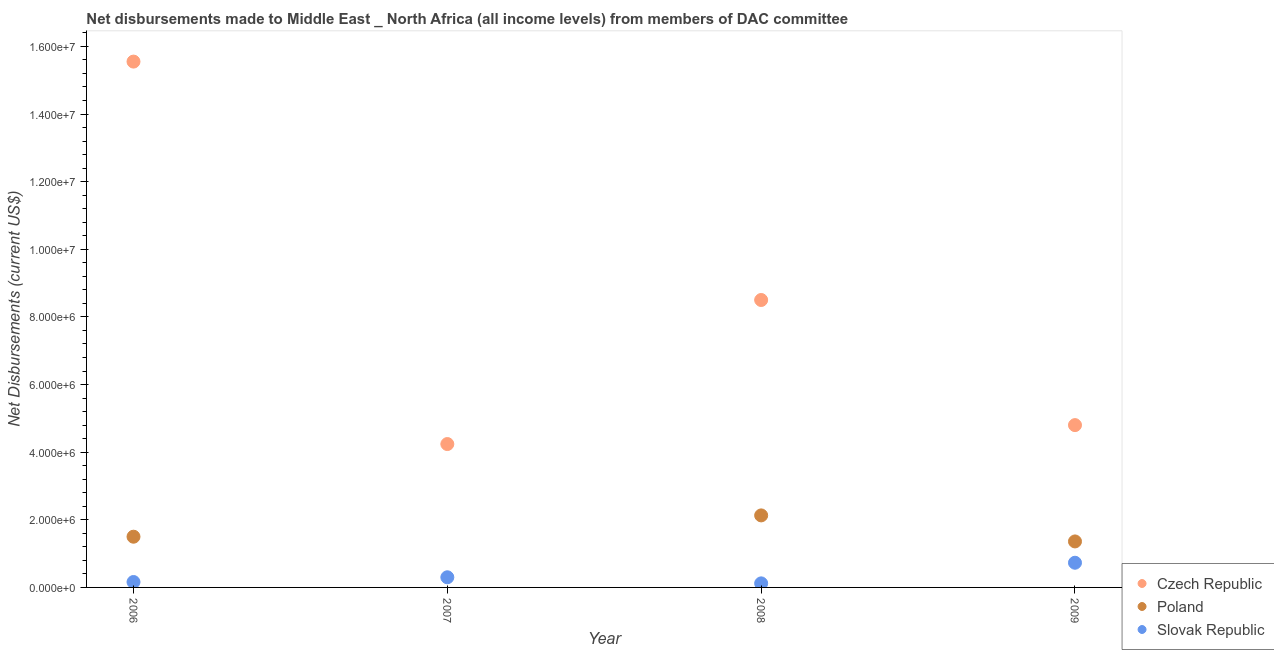What is the net disbursements made by poland in 2006?
Offer a terse response. 1.50e+06. Across all years, what is the maximum net disbursements made by czech republic?
Offer a terse response. 1.56e+07. Across all years, what is the minimum net disbursements made by czech republic?
Ensure brevity in your answer.  4.24e+06. In which year was the net disbursements made by slovak republic maximum?
Keep it short and to the point. 2009. What is the total net disbursements made by poland in the graph?
Give a very brief answer. 4.99e+06. What is the difference between the net disbursements made by czech republic in 2007 and that in 2009?
Ensure brevity in your answer.  -5.60e+05. What is the difference between the net disbursements made by czech republic in 2007 and the net disbursements made by poland in 2008?
Offer a terse response. 2.11e+06. What is the average net disbursements made by slovak republic per year?
Your answer should be compact. 3.28e+05. In the year 2007, what is the difference between the net disbursements made by czech republic and net disbursements made by slovak republic?
Provide a succinct answer. 3.94e+06. In how many years, is the net disbursements made by czech republic greater than 1200000 US$?
Offer a terse response. 4. What is the ratio of the net disbursements made by slovak republic in 2007 to that in 2009?
Your answer should be compact. 0.41. Is the net disbursements made by slovak republic in 2007 less than that in 2008?
Offer a very short reply. No. Is the difference between the net disbursements made by czech republic in 2008 and 2009 greater than the difference between the net disbursements made by poland in 2008 and 2009?
Your response must be concise. Yes. What is the difference between the highest and the second highest net disbursements made by poland?
Your answer should be very brief. 6.30e+05. What is the difference between the highest and the lowest net disbursements made by czech republic?
Make the answer very short. 1.13e+07. Is the sum of the net disbursements made by czech republic in 2006 and 2009 greater than the maximum net disbursements made by poland across all years?
Offer a very short reply. Yes. Is it the case that in every year, the sum of the net disbursements made by czech republic and net disbursements made by poland is greater than the net disbursements made by slovak republic?
Provide a short and direct response. Yes. Does the net disbursements made by slovak republic monotonically increase over the years?
Your answer should be very brief. No. Is the net disbursements made by czech republic strictly greater than the net disbursements made by poland over the years?
Offer a terse response. Yes. Is the net disbursements made by slovak republic strictly less than the net disbursements made by poland over the years?
Make the answer very short. No. How many years are there in the graph?
Your response must be concise. 4. What is the difference between two consecutive major ticks on the Y-axis?
Offer a terse response. 2.00e+06. Are the values on the major ticks of Y-axis written in scientific E-notation?
Offer a terse response. Yes. Does the graph contain any zero values?
Make the answer very short. Yes. Where does the legend appear in the graph?
Provide a short and direct response. Bottom right. What is the title of the graph?
Keep it short and to the point. Net disbursements made to Middle East _ North Africa (all income levels) from members of DAC committee. Does "Wage workers" appear as one of the legend labels in the graph?
Provide a short and direct response. No. What is the label or title of the Y-axis?
Your answer should be very brief. Net Disbursements (current US$). What is the Net Disbursements (current US$) of Czech Republic in 2006?
Ensure brevity in your answer.  1.56e+07. What is the Net Disbursements (current US$) in Poland in 2006?
Give a very brief answer. 1.50e+06. What is the Net Disbursements (current US$) in Czech Republic in 2007?
Offer a very short reply. 4.24e+06. What is the Net Disbursements (current US$) of Czech Republic in 2008?
Offer a terse response. 8.50e+06. What is the Net Disbursements (current US$) in Poland in 2008?
Make the answer very short. 2.13e+06. What is the Net Disbursements (current US$) in Czech Republic in 2009?
Provide a short and direct response. 4.80e+06. What is the Net Disbursements (current US$) of Poland in 2009?
Keep it short and to the point. 1.36e+06. What is the Net Disbursements (current US$) of Slovak Republic in 2009?
Your answer should be compact. 7.30e+05. Across all years, what is the maximum Net Disbursements (current US$) of Czech Republic?
Your answer should be very brief. 1.56e+07. Across all years, what is the maximum Net Disbursements (current US$) in Poland?
Your answer should be compact. 2.13e+06. Across all years, what is the maximum Net Disbursements (current US$) in Slovak Republic?
Your answer should be very brief. 7.30e+05. Across all years, what is the minimum Net Disbursements (current US$) of Czech Republic?
Offer a very short reply. 4.24e+06. Across all years, what is the minimum Net Disbursements (current US$) of Poland?
Keep it short and to the point. 0. What is the total Net Disbursements (current US$) in Czech Republic in the graph?
Your answer should be very brief. 3.31e+07. What is the total Net Disbursements (current US$) of Poland in the graph?
Your answer should be very brief. 4.99e+06. What is the total Net Disbursements (current US$) in Slovak Republic in the graph?
Provide a short and direct response. 1.31e+06. What is the difference between the Net Disbursements (current US$) in Czech Republic in 2006 and that in 2007?
Give a very brief answer. 1.13e+07. What is the difference between the Net Disbursements (current US$) in Slovak Republic in 2006 and that in 2007?
Keep it short and to the point. -1.40e+05. What is the difference between the Net Disbursements (current US$) in Czech Republic in 2006 and that in 2008?
Give a very brief answer. 7.05e+06. What is the difference between the Net Disbursements (current US$) of Poland in 2006 and that in 2008?
Your response must be concise. -6.30e+05. What is the difference between the Net Disbursements (current US$) of Slovak Republic in 2006 and that in 2008?
Your answer should be very brief. 4.00e+04. What is the difference between the Net Disbursements (current US$) in Czech Republic in 2006 and that in 2009?
Make the answer very short. 1.08e+07. What is the difference between the Net Disbursements (current US$) in Poland in 2006 and that in 2009?
Keep it short and to the point. 1.40e+05. What is the difference between the Net Disbursements (current US$) in Slovak Republic in 2006 and that in 2009?
Offer a terse response. -5.70e+05. What is the difference between the Net Disbursements (current US$) in Czech Republic in 2007 and that in 2008?
Your answer should be compact. -4.26e+06. What is the difference between the Net Disbursements (current US$) of Slovak Republic in 2007 and that in 2008?
Your answer should be very brief. 1.80e+05. What is the difference between the Net Disbursements (current US$) of Czech Republic in 2007 and that in 2009?
Ensure brevity in your answer.  -5.60e+05. What is the difference between the Net Disbursements (current US$) of Slovak Republic in 2007 and that in 2009?
Make the answer very short. -4.30e+05. What is the difference between the Net Disbursements (current US$) of Czech Republic in 2008 and that in 2009?
Provide a short and direct response. 3.70e+06. What is the difference between the Net Disbursements (current US$) of Poland in 2008 and that in 2009?
Provide a succinct answer. 7.70e+05. What is the difference between the Net Disbursements (current US$) of Slovak Republic in 2008 and that in 2009?
Your response must be concise. -6.10e+05. What is the difference between the Net Disbursements (current US$) of Czech Republic in 2006 and the Net Disbursements (current US$) of Slovak Republic in 2007?
Make the answer very short. 1.52e+07. What is the difference between the Net Disbursements (current US$) in Poland in 2006 and the Net Disbursements (current US$) in Slovak Republic in 2007?
Make the answer very short. 1.20e+06. What is the difference between the Net Disbursements (current US$) in Czech Republic in 2006 and the Net Disbursements (current US$) in Poland in 2008?
Your answer should be very brief. 1.34e+07. What is the difference between the Net Disbursements (current US$) of Czech Republic in 2006 and the Net Disbursements (current US$) of Slovak Republic in 2008?
Provide a succinct answer. 1.54e+07. What is the difference between the Net Disbursements (current US$) in Poland in 2006 and the Net Disbursements (current US$) in Slovak Republic in 2008?
Offer a very short reply. 1.38e+06. What is the difference between the Net Disbursements (current US$) of Czech Republic in 2006 and the Net Disbursements (current US$) of Poland in 2009?
Ensure brevity in your answer.  1.42e+07. What is the difference between the Net Disbursements (current US$) of Czech Republic in 2006 and the Net Disbursements (current US$) of Slovak Republic in 2009?
Your answer should be very brief. 1.48e+07. What is the difference between the Net Disbursements (current US$) in Poland in 2006 and the Net Disbursements (current US$) in Slovak Republic in 2009?
Your response must be concise. 7.70e+05. What is the difference between the Net Disbursements (current US$) of Czech Republic in 2007 and the Net Disbursements (current US$) of Poland in 2008?
Offer a terse response. 2.11e+06. What is the difference between the Net Disbursements (current US$) in Czech Republic in 2007 and the Net Disbursements (current US$) in Slovak Republic in 2008?
Your answer should be compact. 4.12e+06. What is the difference between the Net Disbursements (current US$) in Czech Republic in 2007 and the Net Disbursements (current US$) in Poland in 2009?
Give a very brief answer. 2.88e+06. What is the difference between the Net Disbursements (current US$) of Czech Republic in 2007 and the Net Disbursements (current US$) of Slovak Republic in 2009?
Make the answer very short. 3.51e+06. What is the difference between the Net Disbursements (current US$) of Czech Republic in 2008 and the Net Disbursements (current US$) of Poland in 2009?
Ensure brevity in your answer.  7.14e+06. What is the difference between the Net Disbursements (current US$) in Czech Republic in 2008 and the Net Disbursements (current US$) in Slovak Republic in 2009?
Make the answer very short. 7.77e+06. What is the difference between the Net Disbursements (current US$) of Poland in 2008 and the Net Disbursements (current US$) of Slovak Republic in 2009?
Provide a succinct answer. 1.40e+06. What is the average Net Disbursements (current US$) of Czech Republic per year?
Provide a short and direct response. 8.27e+06. What is the average Net Disbursements (current US$) of Poland per year?
Make the answer very short. 1.25e+06. What is the average Net Disbursements (current US$) of Slovak Republic per year?
Provide a short and direct response. 3.28e+05. In the year 2006, what is the difference between the Net Disbursements (current US$) in Czech Republic and Net Disbursements (current US$) in Poland?
Offer a very short reply. 1.40e+07. In the year 2006, what is the difference between the Net Disbursements (current US$) in Czech Republic and Net Disbursements (current US$) in Slovak Republic?
Offer a very short reply. 1.54e+07. In the year 2006, what is the difference between the Net Disbursements (current US$) of Poland and Net Disbursements (current US$) of Slovak Republic?
Your answer should be compact. 1.34e+06. In the year 2007, what is the difference between the Net Disbursements (current US$) in Czech Republic and Net Disbursements (current US$) in Slovak Republic?
Give a very brief answer. 3.94e+06. In the year 2008, what is the difference between the Net Disbursements (current US$) in Czech Republic and Net Disbursements (current US$) in Poland?
Keep it short and to the point. 6.37e+06. In the year 2008, what is the difference between the Net Disbursements (current US$) of Czech Republic and Net Disbursements (current US$) of Slovak Republic?
Provide a short and direct response. 8.38e+06. In the year 2008, what is the difference between the Net Disbursements (current US$) in Poland and Net Disbursements (current US$) in Slovak Republic?
Give a very brief answer. 2.01e+06. In the year 2009, what is the difference between the Net Disbursements (current US$) in Czech Republic and Net Disbursements (current US$) in Poland?
Offer a very short reply. 3.44e+06. In the year 2009, what is the difference between the Net Disbursements (current US$) in Czech Republic and Net Disbursements (current US$) in Slovak Republic?
Provide a succinct answer. 4.07e+06. In the year 2009, what is the difference between the Net Disbursements (current US$) of Poland and Net Disbursements (current US$) of Slovak Republic?
Make the answer very short. 6.30e+05. What is the ratio of the Net Disbursements (current US$) of Czech Republic in 2006 to that in 2007?
Keep it short and to the point. 3.67. What is the ratio of the Net Disbursements (current US$) of Slovak Republic in 2006 to that in 2007?
Offer a terse response. 0.53. What is the ratio of the Net Disbursements (current US$) in Czech Republic in 2006 to that in 2008?
Your answer should be very brief. 1.83. What is the ratio of the Net Disbursements (current US$) of Poland in 2006 to that in 2008?
Give a very brief answer. 0.7. What is the ratio of the Net Disbursements (current US$) of Slovak Republic in 2006 to that in 2008?
Make the answer very short. 1.33. What is the ratio of the Net Disbursements (current US$) of Czech Republic in 2006 to that in 2009?
Offer a terse response. 3.24. What is the ratio of the Net Disbursements (current US$) in Poland in 2006 to that in 2009?
Give a very brief answer. 1.1. What is the ratio of the Net Disbursements (current US$) in Slovak Republic in 2006 to that in 2009?
Offer a terse response. 0.22. What is the ratio of the Net Disbursements (current US$) in Czech Republic in 2007 to that in 2008?
Your answer should be very brief. 0.5. What is the ratio of the Net Disbursements (current US$) in Slovak Republic in 2007 to that in 2008?
Your answer should be very brief. 2.5. What is the ratio of the Net Disbursements (current US$) of Czech Republic in 2007 to that in 2009?
Provide a short and direct response. 0.88. What is the ratio of the Net Disbursements (current US$) in Slovak Republic in 2007 to that in 2009?
Make the answer very short. 0.41. What is the ratio of the Net Disbursements (current US$) in Czech Republic in 2008 to that in 2009?
Offer a very short reply. 1.77. What is the ratio of the Net Disbursements (current US$) of Poland in 2008 to that in 2009?
Your answer should be very brief. 1.57. What is the ratio of the Net Disbursements (current US$) of Slovak Republic in 2008 to that in 2009?
Your response must be concise. 0.16. What is the difference between the highest and the second highest Net Disbursements (current US$) in Czech Republic?
Offer a very short reply. 7.05e+06. What is the difference between the highest and the second highest Net Disbursements (current US$) of Poland?
Give a very brief answer. 6.30e+05. What is the difference between the highest and the lowest Net Disbursements (current US$) of Czech Republic?
Ensure brevity in your answer.  1.13e+07. What is the difference between the highest and the lowest Net Disbursements (current US$) in Poland?
Offer a terse response. 2.13e+06. 